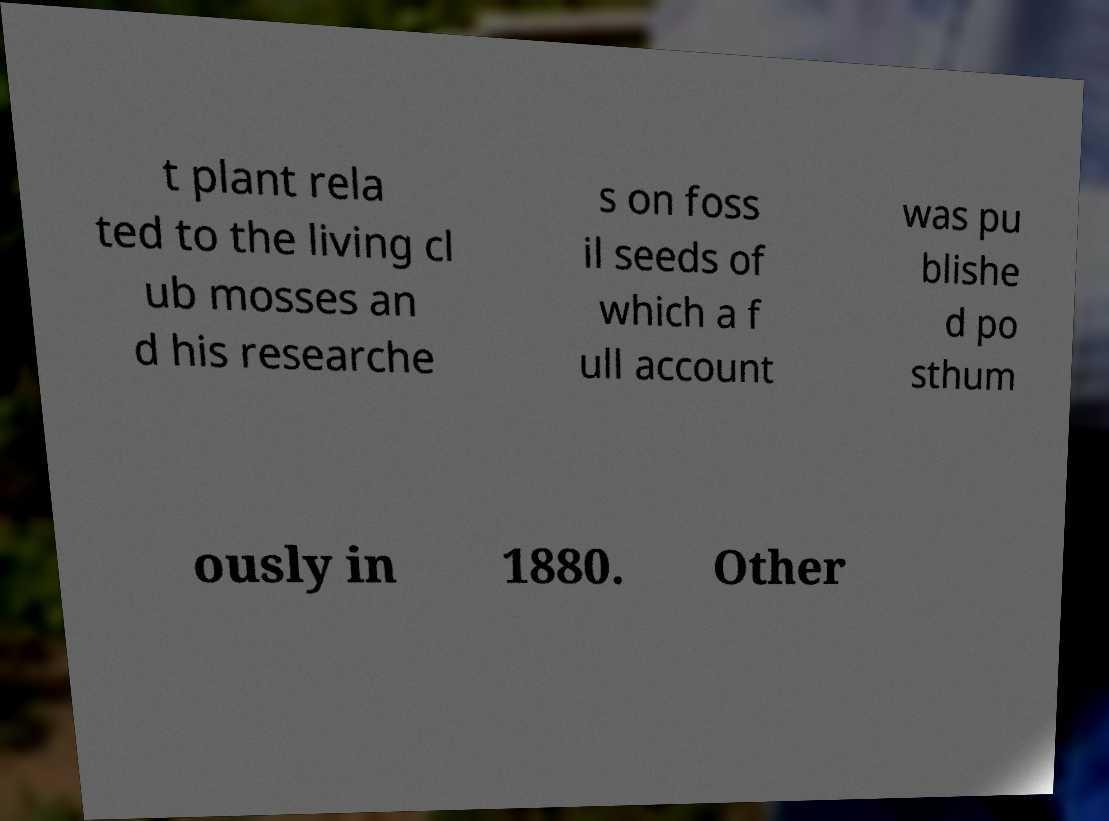Please read and relay the text visible in this image. What does it say? t plant rela ted to the living cl ub mosses an d his researche s on foss il seeds of which a f ull account was pu blishe d po sthum ously in 1880. Other 